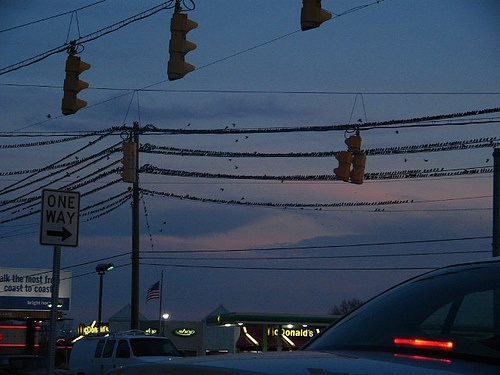Describe the objects in this image and their specific colors. I can see bird in darkblue, gray, black, and navy tones, car in darkblue, black, navy, and red tones, truck in darkblue, black, navy, and gray tones, traffic light in darkblue, black, gray, and blue tones, and traffic light in darkblue, black, gray, and blue tones in this image. 